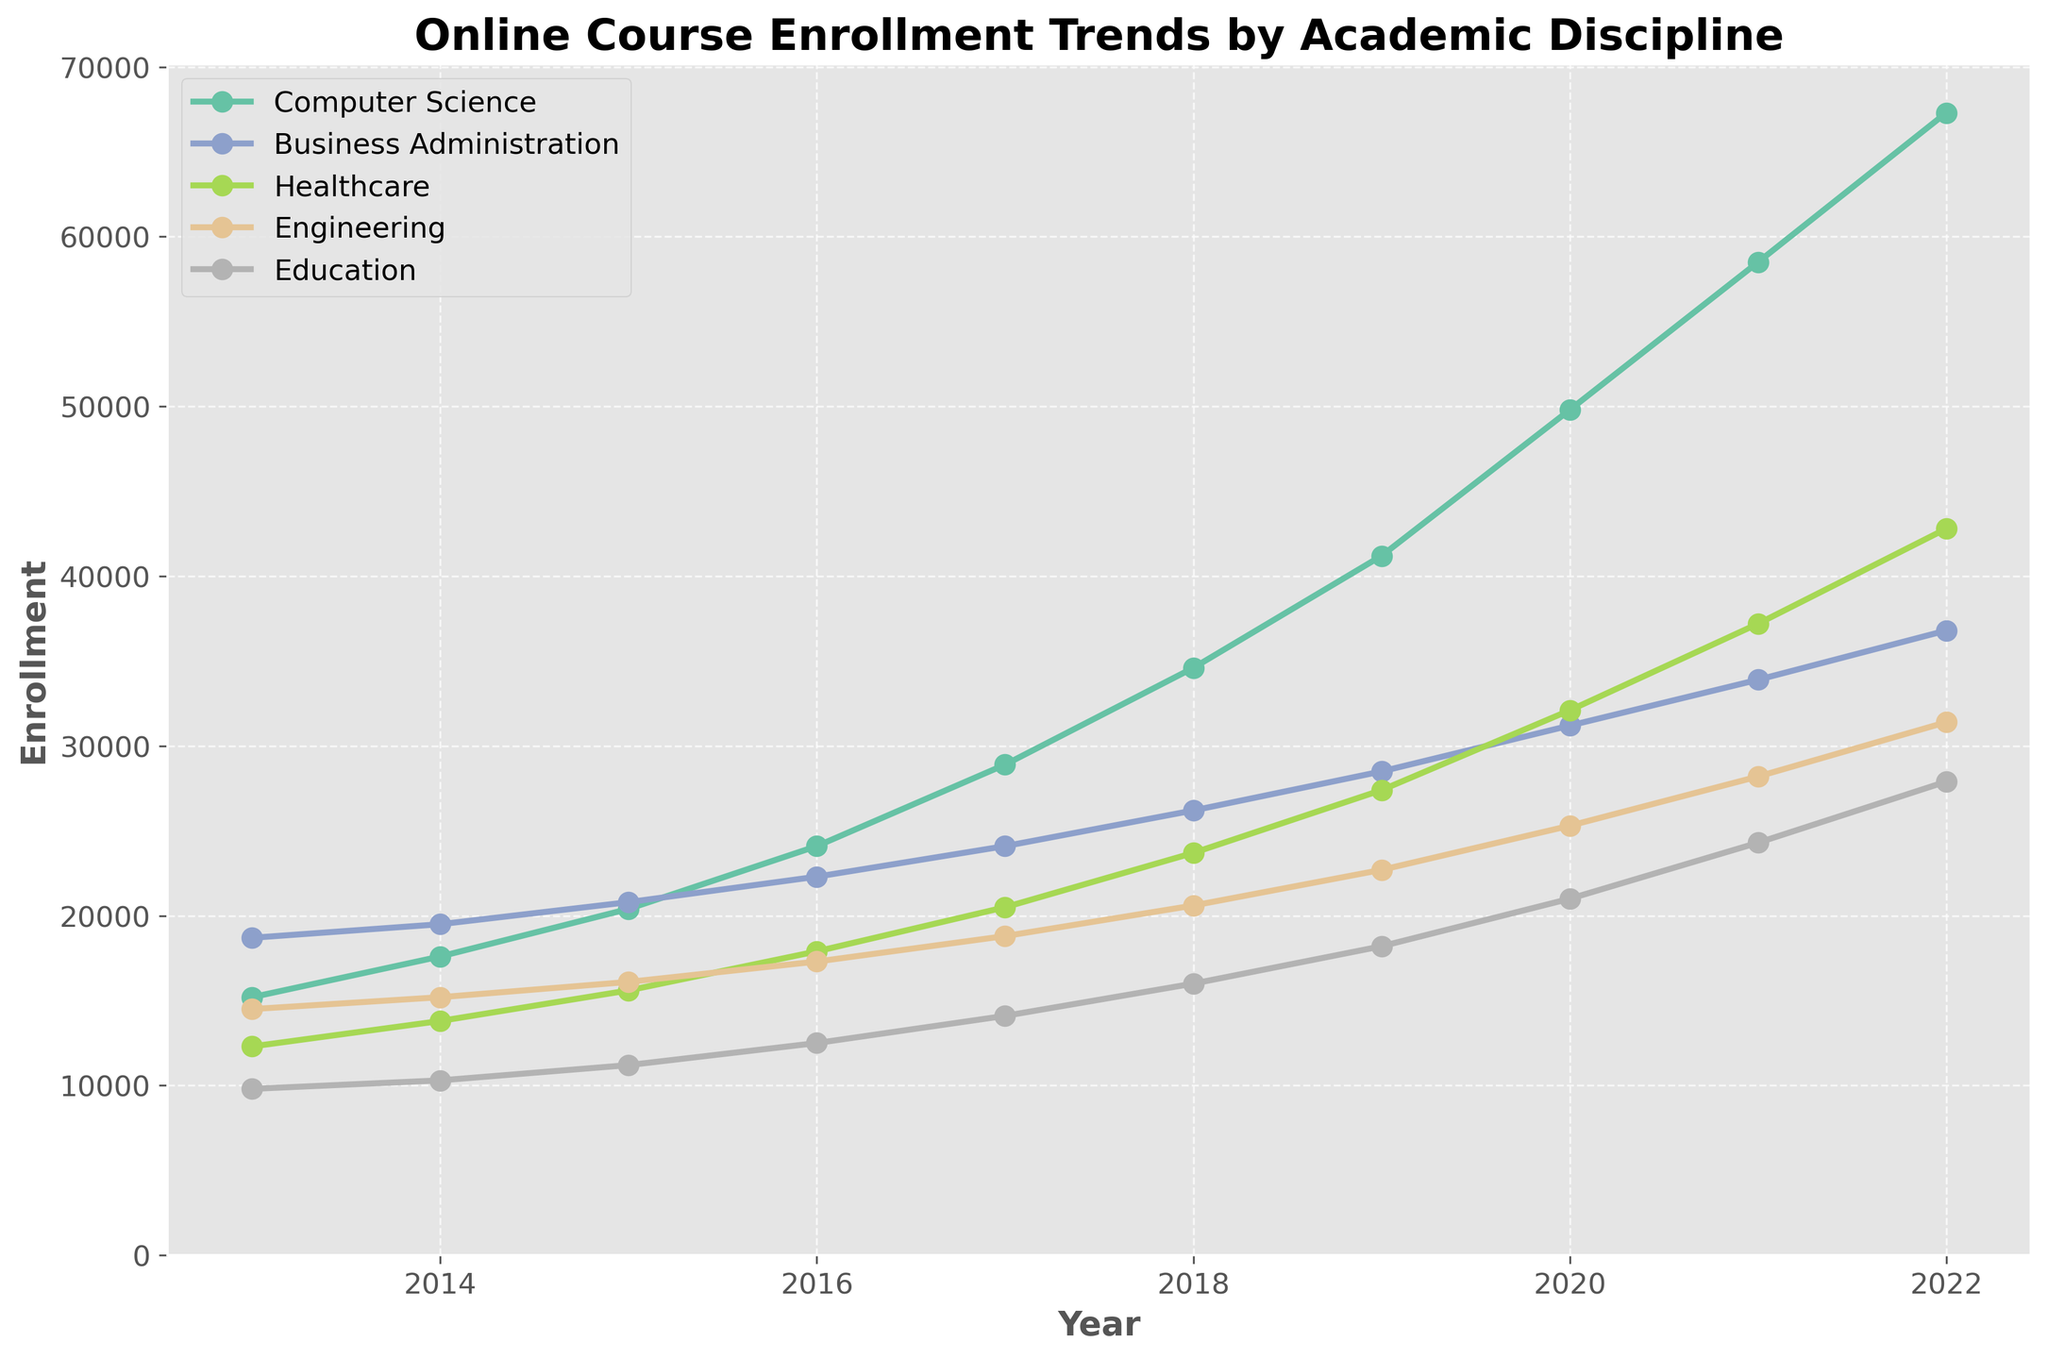What's the trend in enrollment for Computer Science from 2013 to 2022? We need to observe the line representing Computer Science between 2013 and 2022 on the plot. It steadily increases in enrollment year over year.
Answer: Increasing Which academic discipline had the highest enrollment in 2022? We locate 2022 on the x-axis and identify which line reaches the highest point on the y-axis for that year. Computer Science's line is the highest.
Answer: Computer Science By how much did enrollment in Healthcare grow between 2013 and 2022? We need to find the difference between Healthcare’s enrollment numbers in 2022 and 2013. In 2013, it was 12,300, and in 2022, it was 42,800. Thus, the growth is 42,800 - 12,300.
Answer: 30,500 Which discipline shows the most consistent growth trend? We look at the smoothness and stability of the lines representing each discipline. Computer Science displays steady and consistent growth without fluctuating.
Answer: Computer Science How does the enrollment trend for Education compare to that of Engineering in 2020? For the year 2020, we compare the enrollment numbers of Education and Engineering by looking at their respective points on the y-axis. Engineering (25,300) is higher than Education (21,000).
Answer: Engineering is higher What was the average enrollment in Business Administration from 2013 to 2022? We sum the enrollment numbers for Business Administration over the years 2013 to 2022: 18,700 + 19,500 + 20,800 + 22,300 + 24,100 + 26,200 + 28,500 + 31,200 + 33,900 + 36,800. Then, divide by 10.
Answer: 26,100 Which discipline had the least growth in enrollment from 2013 to 2022? We find the growth for each discipline by subtracting their 2013 values from their 2022 values. Education: 27,900 - 9,800 = 18,100, which is the smallest increase among the disciplines.
Answer: Education Which two disciplines had a crossover in their enrollment trends, and in which year did it occur? We identify where two lines intersect on the plot. Engineering and Healthcare crossed in 2020.
Answer: Healthcare and Engineering, 2020 